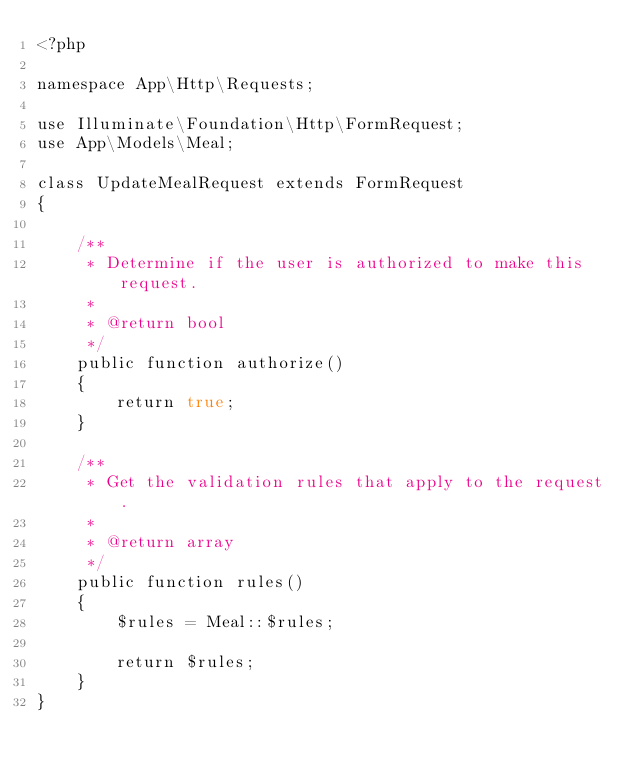Convert code to text. <code><loc_0><loc_0><loc_500><loc_500><_PHP_><?php

namespace App\Http\Requests;

use Illuminate\Foundation\Http\FormRequest;
use App\Models\Meal;

class UpdateMealRequest extends FormRequest
{

    /**
     * Determine if the user is authorized to make this request.
     *
     * @return bool
     */
    public function authorize()
    {
        return true;
    }

    /**
     * Get the validation rules that apply to the request.
     *
     * @return array
     */
    public function rules()
    {
        $rules = Meal::$rules;
        
        return $rules;
    }
}
</code> 